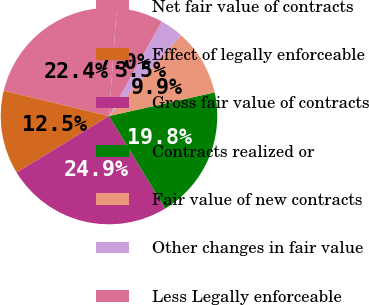<chart> <loc_0><loc_0><loc_500><loc_500><pie_chart><fcel>Net fair value of contracts<fcel>Effect of legally enforceable<fcel>Gross fair value of contracts<fcel>Contracts realized or<fcel>Fair value of new contracts<fcel>Other changes in fair value<fcel>Less Legally enforceable<nl><fcel>22.39%<fcel>12.48%<fcel>24.95%<fcel>19.83%<fcel>9.92%<fcel>3.48%<fcel>6.96%<nl></chart> 